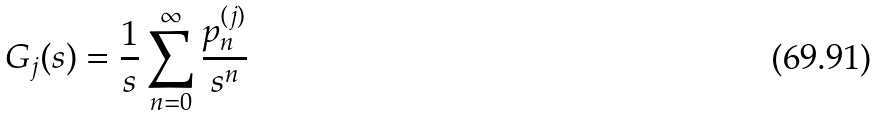<formula> <loc_0><loc_0><loc_500><loc_500>G _ { j } ( s ) = \frac { 1 } { s } \sum _ { n = 0 } ^ { \infty } \frac { p _ { n } ^ { ( j ) } } { s ^ { n } }</formula> 